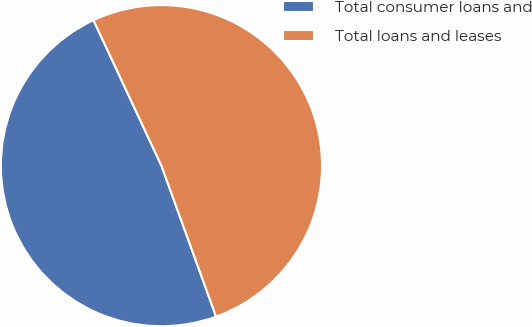Convert chart to OTSL. <chart><loc_0><loc_0><loc_500><loc_500><pie_chart><fcel>Total consumer loans and<fcel>Total loans and leases<nl><fcel>48.58%<fcel>51.42%<nl></chart> 